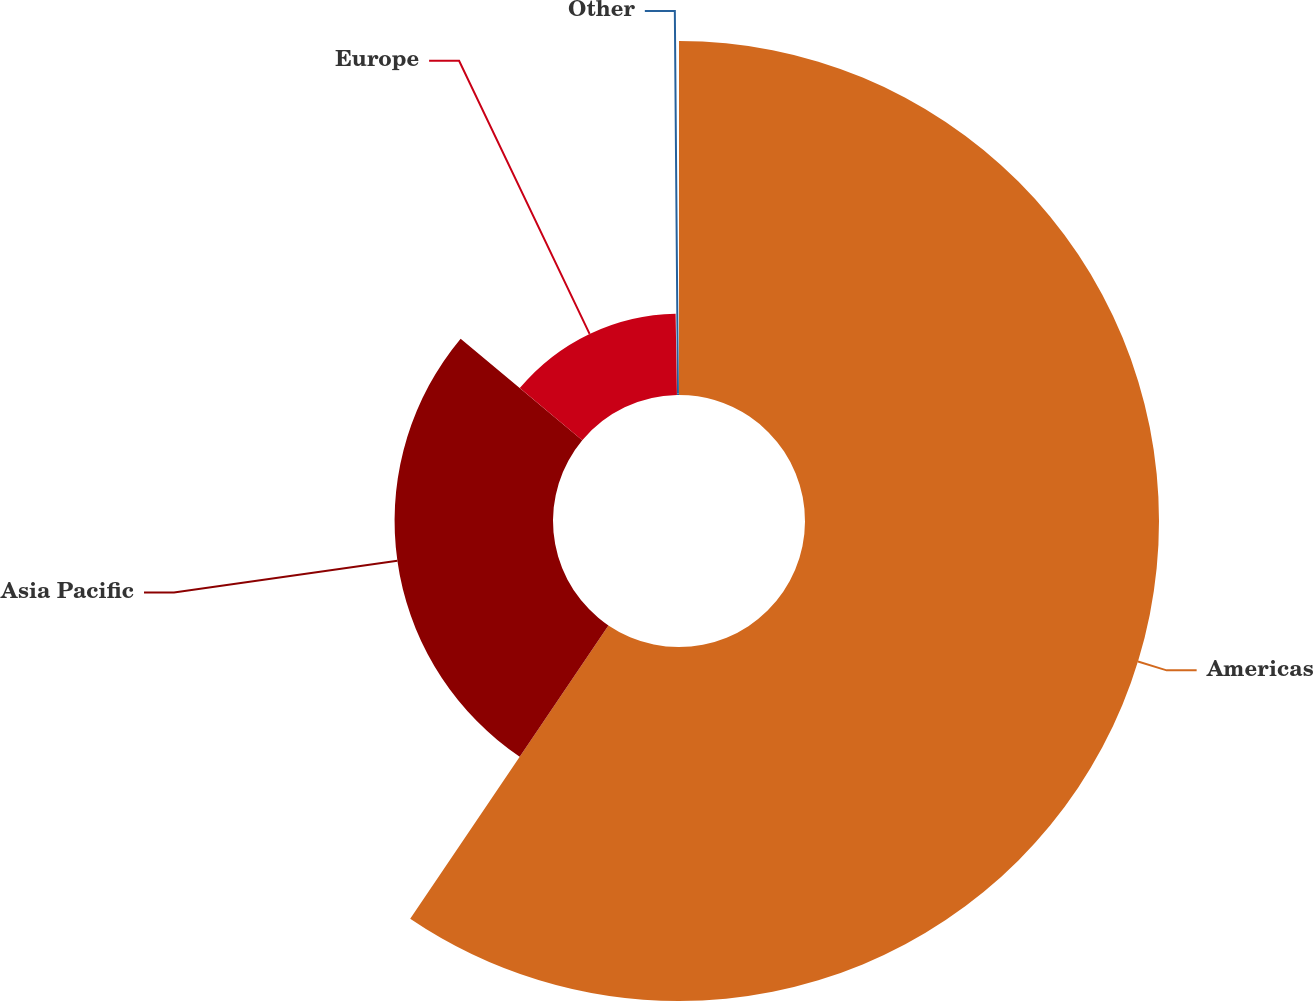Convert chart. <chart><loc_0><loc_0><loc_500><loc_500><pie_chart><fcel>Americas<fcel>Asia Pacific<fcel>Europe<fcel>Other<nl><fcel>59.46%<fcel>26.61%<fcel>13.67%<fcel>0.26%<nl></chart> 